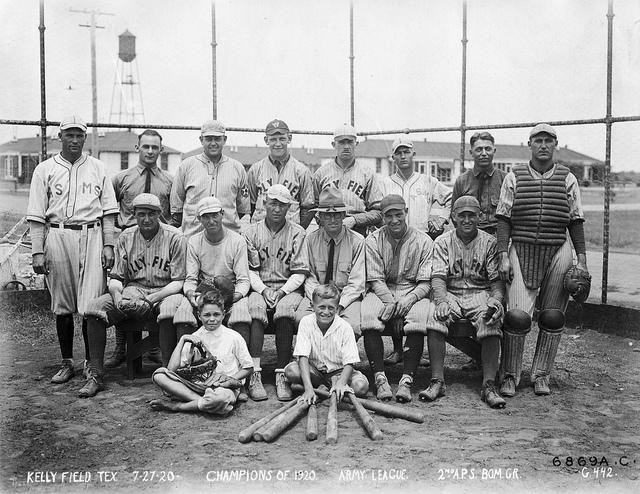What sport do these men play?
Write a very short answer. Baseball. What team do these men play on?
Quick response, please. Baseball. Is this an older photo?
Write a very short answer. Yes. Is this photo colorful?
Keep it brief. No. How many baseball players are in this picture?
Be succinct. 16. 